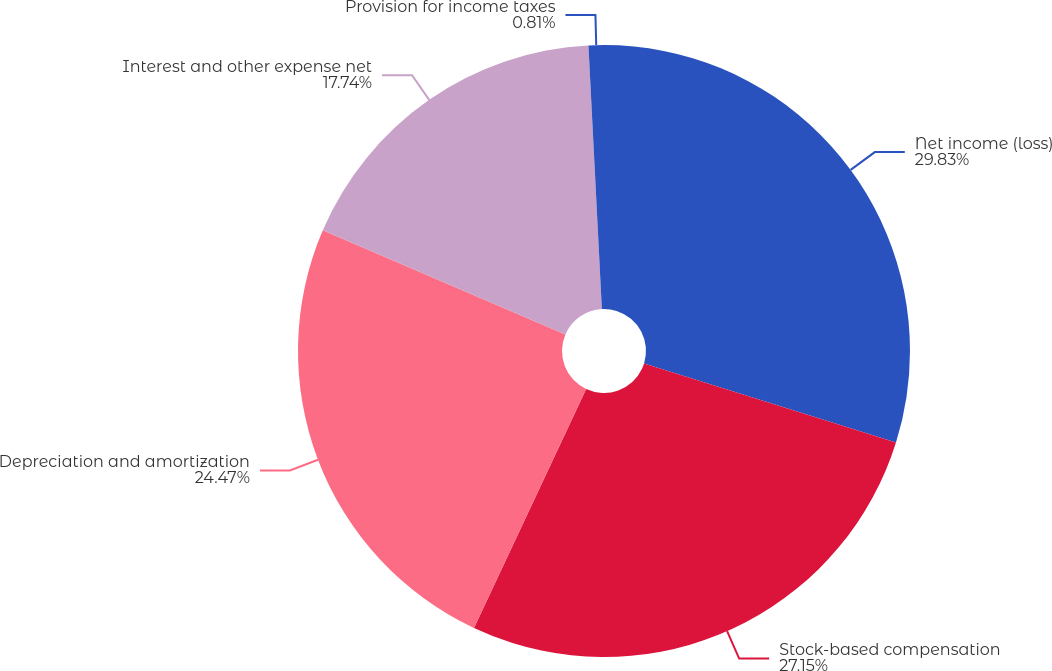Convert chart. <chart><loc_0><loc_0><loc_500><loc_500><pie_chart><fcel>Net income (loss)<fcel>Stock-based compensation<fcel>Depreciation and amortization<fcel>Interest and other expense net<fcel>Provision for income taxes<nl><fcel>29.84%<fcel>27.15%<fcel>24.47%<fcel>17.74%<fcel>0.81%<nl></chart> 